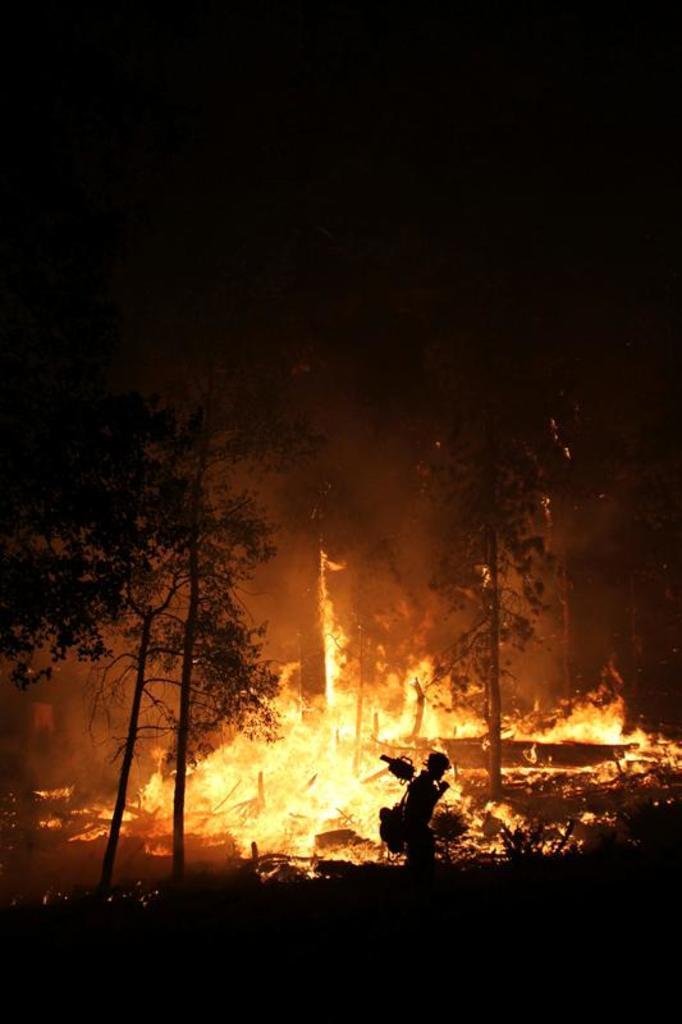Please provide a concise description of this image. In this image there is a person carrying a bag. There are trees. Behind there is fire. 